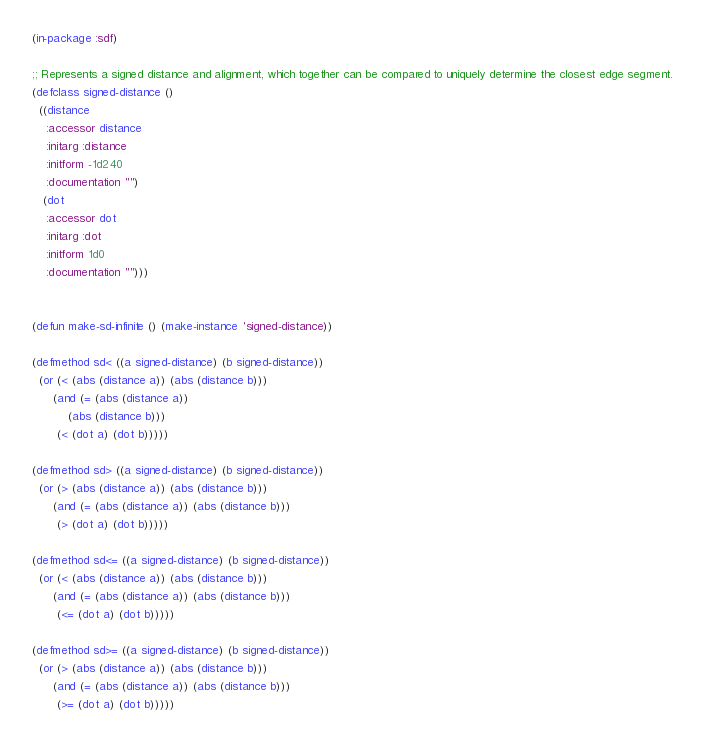<code> <loc_0><loc_0><loc_500><loc_500><_Lisp_>(in-package :sdf)

;; Represents a signed distance and alignment, which together can be compared to uniquely determine the closest edge segment.
(defclass signed-distance ()
  ((distance
    :accessor distance
    :initarg :distance
    :initform -1d240
    :documentation "")
   (dot
    :accessor dot
    :initarg :dot
    :initform 1d0
    :documentation "")))


(defun make-sd-infinite () (make-instance 'signed-distance))

(defmethod sd< ((a signed-distance) (b signed-distance))
  (or (< (abs (distance a)) (abs (distance b)))
      (and (= (abs (distance a))
	      (abs (distance b)))
	   (< (dot a) (dot b)))))

(defmethod sd> ((a signed-distance) (b signed-distance))
  (or (> (abs (distance a)) (abs (distance b)))
      (and (= (abs (distance a)) (abs (distance b)))
	   (> (dot a) (dot b)))))

(defmethod sd<= ((a signed-distance) (b signed-distance))
  (or (< (abs (distance a)) (abs (distance b)))
      (and (= (abs (distance a)) (abs (distance b)))
	   (<= (dot a) (dot b)))))

(defmethod sd>= ((a signed-distance) (b signed-distance))
  (or (> (abs (distance a)) (abs (distance b)))
      (and (= (abs (distance a)) (abs (distance b)))
	   (>= (dot a) (dot b)))))
</code> 